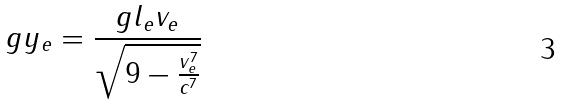<formula> <loc_0><loc_0><loc_500><loc_500>g y _ { e } = \frac { g l _ { e } v _ { e } } { \sqrt { 9 - \frac { v _ { e } ^ { 7 } } { c ^ { 7 } } } }</formula> 